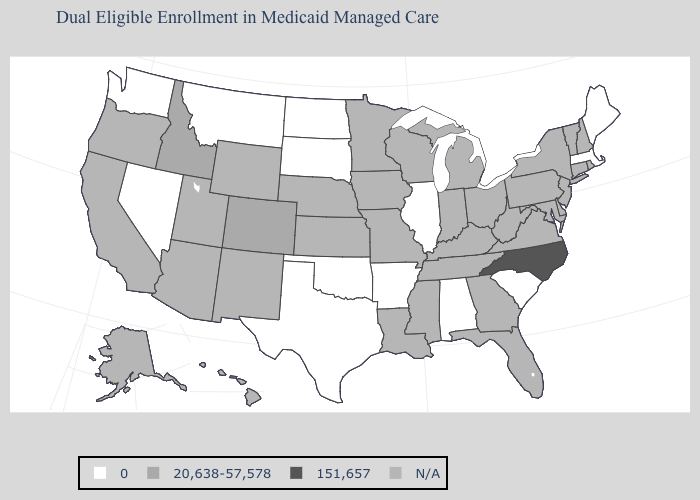What is the value of Ohio?
Write a very short answer. N/A. What is the value of South Carolina?
Give a very brief answer. 0. Among the states that border Vermont , which have the lowest value?
Be succinct. Massachusetts. What is the value of Pennsylvania?
Keep it brief. N/A. Which states have the lowest value in the USA?
Write a very short answer. Alabama, Arkansas, Illinois, Maine, Massachusetts, Montana, Nevada, North Dakota, Oklahoma, South Carolina, South Dakota, Texas, Washington. What is the highest value in the USA?
Concise answer only. 151,657. What is the value of Delaware?
Short answer required. N/A. What is the lowest value in the Northeast?
Short answer required. 0. Name the states that have a value in the range N/A?
Short answer required. Alaska, Arizona, California, Connecticut, Delaware, Florida, Georgia, Hawaii, Indiana, Iowa, Kansas, Kentucky, Louisiana, Maryland, Michigan, Minnesota, Mississippi, Missouri, Nebraska, New Hampshire, New Jersey, New Mexico, New York, Ohio, Oregon, Pennsylvania, Rhode Island, Tennessee, Utah, Vermont, Virginia, West Virginia, Wisconsin, Wyoming. Does Colorado have the lowest value in the West?
Keep it brief. No. Is the legend a continuous bar?
Short answer required. No. Name the states that have a value in the range N/A?
Short answer required. Alaska, Arizona, California, Connecticut, Delaware, Florida, Georgia, Hawaii, Indiana, Iowa, Kansas, Kentucky, Louisiana, Maryland, Michigan, Minnesota, Mississippi, Missouri, Nebraska, New Hampshire, New Jersey, New Mexico, New York, Ohio, Oregon, Pennsylvania, Rhode Island, Tennessee, Utah, Vermont, Virginia, West Virginia, Wisconsin, Wyoming. 